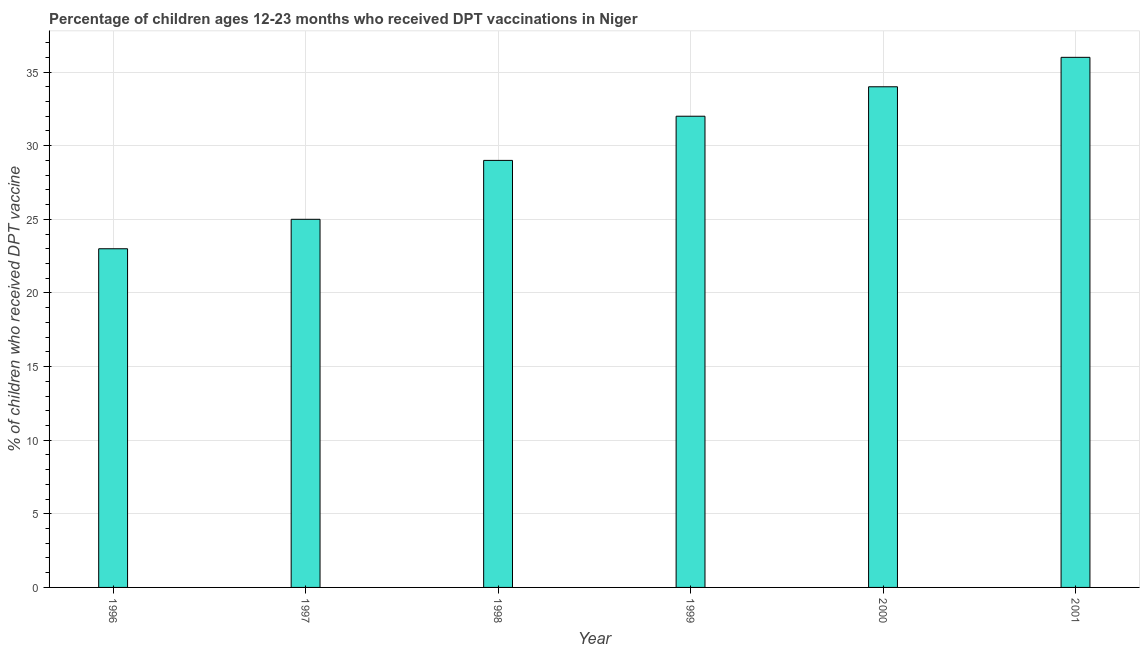Does the graph contain grids?
Provide a short and direct response. Yes. What is the title of the graph?
Your response must be concise. Percentage of children ages 12-23 months who received DPT vaccinations in Niger. What is the label or title of the Y-axis?
Provide a short and direct response. % of children who received DPT vaccine. What is the percentage of children who received dpt vaccine in 1999?
Make the answer very short. 32. Across all years, what is the minimum percentage of children who received dpt vaccine?
Your answer should be compact. 23. What is the sum of the percentage of children who received dpt vaccine?
Provide a short and direct response. 179. What is the difference between the percentage of children who received dpt vaccine in 1997 and 1999?
Your answer should be very brief. -7. What is the median percentage of children who received dpt vaccine?
Ensure brevity in your answer.  30.5. Do a majority of the years between 1999 and 1998 (inclusive) have percentage of children who received dpt vaccine greater than 16 %?
Your answer should be compact. No. What is the ratio of the percentage of children who received dpt vaccine in 1998 to that in 1999?
Make the answer very short. 0.91. What is the difference between the highest and the second highest percentage of children who received dpt vaccine?
Your answer should be compact. 2. In how many years, is the percentage of children who received dpt vaccine greater than the average percentage of children who received dpt vaccine taken over all years?
Make the answer very short. 3. Are all the bars in the graph horizontal?
Provide a succinct answer. No. What is the difference between two consecutive major ticks on the Y-axis?
Offer a terse response. 5. What is the % of children who received DPT vaccine in 1999?
Make the answer very short. 32. What is the difference between the % of children who received DPT vaccine in 1996 and 1999?
Your answer should be very brief. -9. What is the difference between the % of children who received DPT vaccine in 1996 and 2001?
Offer a terse response. -13. What is the difference between the % of children who received DPT vaccine in 1997 and 1998?
Offer a terse response. -4. What is the difference between the % of children who received DPT vaccine in 1997 and 1999?
Keep it short and to the point. -7. What is the difference between the % of children who received DPT vaccine in 1997 and 2000?
Make the answer very short. -9. What is the difference between the % of children who received DPT vaccine in 1997 and 2001?
Give a very brief answer. -11. What is the difference between the % of children who received DPT vaccine in 1998 and 1999?
Your answer should be compact. -3. What is the difference between the % of children who received DPT vaccine in 1998 and 2000?
Make the answer very short. -5. What is the difference between the % of children who received DPT vaccine in 1998 and 2001?
Your answer should be compact. -7. What is the difference between the % of children who received DPT vaccine in 2000 and 2001?
Offer a very short reply. -2. What is the ratio of the % of children who received DPT vaccine in 1996 to that in 1998?
Offer a terse response. 0.79. What is the ratio of the % of children who received DPT vaccine in 1996 to that in 1999?
Provide a succinct answer. 0.72. What is the ratio of the % of children who received DPT vaccine in 1996 to that in 2000?
Keep it short and to the point. 0.68. What is the ratio of the % of children who received DPT vaccine in 1996 to that in 2001?
Make the answer very short. 0.64. What is the ratio of the % of children who received DPT vaccine in 1997 to that in 1998?
Offer a very short reply. 0.86. What is the ratio of the % of children who received DPT vaccine in 1997 to that in 1999?
Give a very brief answer. 0.78. What is the ratio of the % of children who received DPT vaccine in 1997 to that in 2000?
Keep it short and to the point. 0.73. What is the ratio of the % of children who received DPT vaccine in 1997 to that in 2001?
Give a very brief answer. 0.69. What is the ratio of the % of children who received DPT vaccine in 1998 to that in 1999?
Give a very brief answer. 0.91. What is the ratio of the % of children who received DPT vaccine in 1998 to that in 2000?
Provide a short and direct response. 0.85. What is the ratio of the % of children who received DPT vaccine in 1998 to that in 2001?
Make the answer very short. 0.81. What is the ratio of the % of children who received DPT vaccine in 1999 to that in 2000?
Your response must be concise. 0.94. What is the ratio of the % of children who received DPT vaccine in 1999 to that in 2001?
Offer a very short reply. 0.89. What is the ratio of the % of children who received DPT vaccine in 2000 to that in 2001?
Keep it short and to the point. 0.94. 